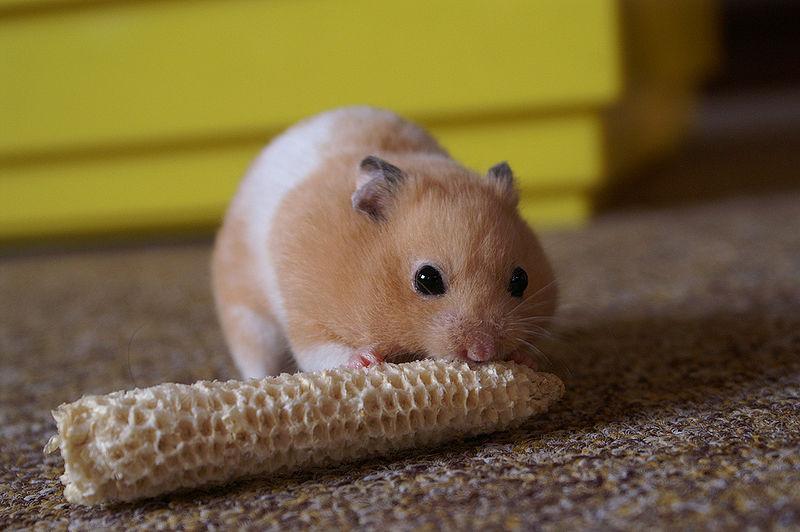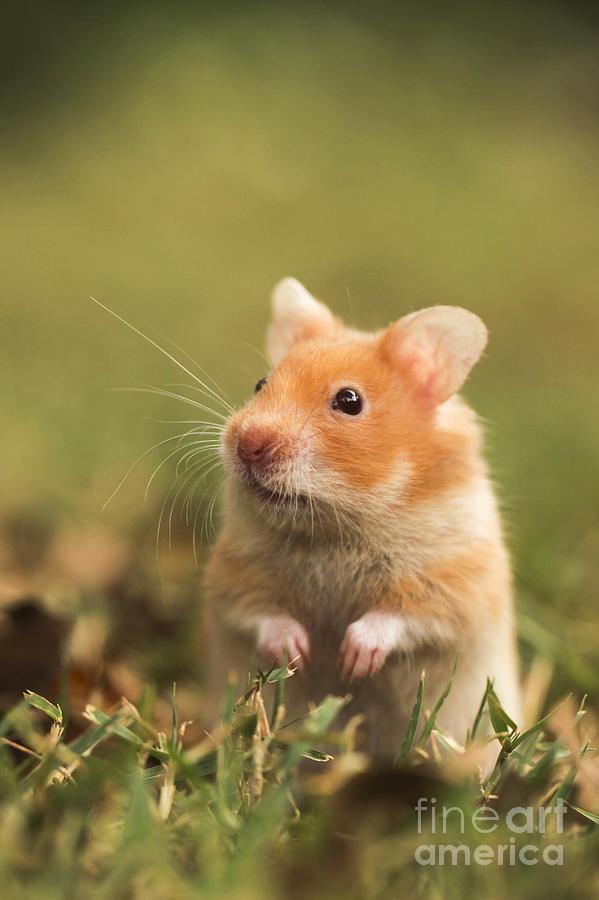The first image is the image on the left, the second image is the image on the right. Assess this claim about the two images: "the mouse on the left image is eating something". Correct or not? Answer yes or no. Yes. 